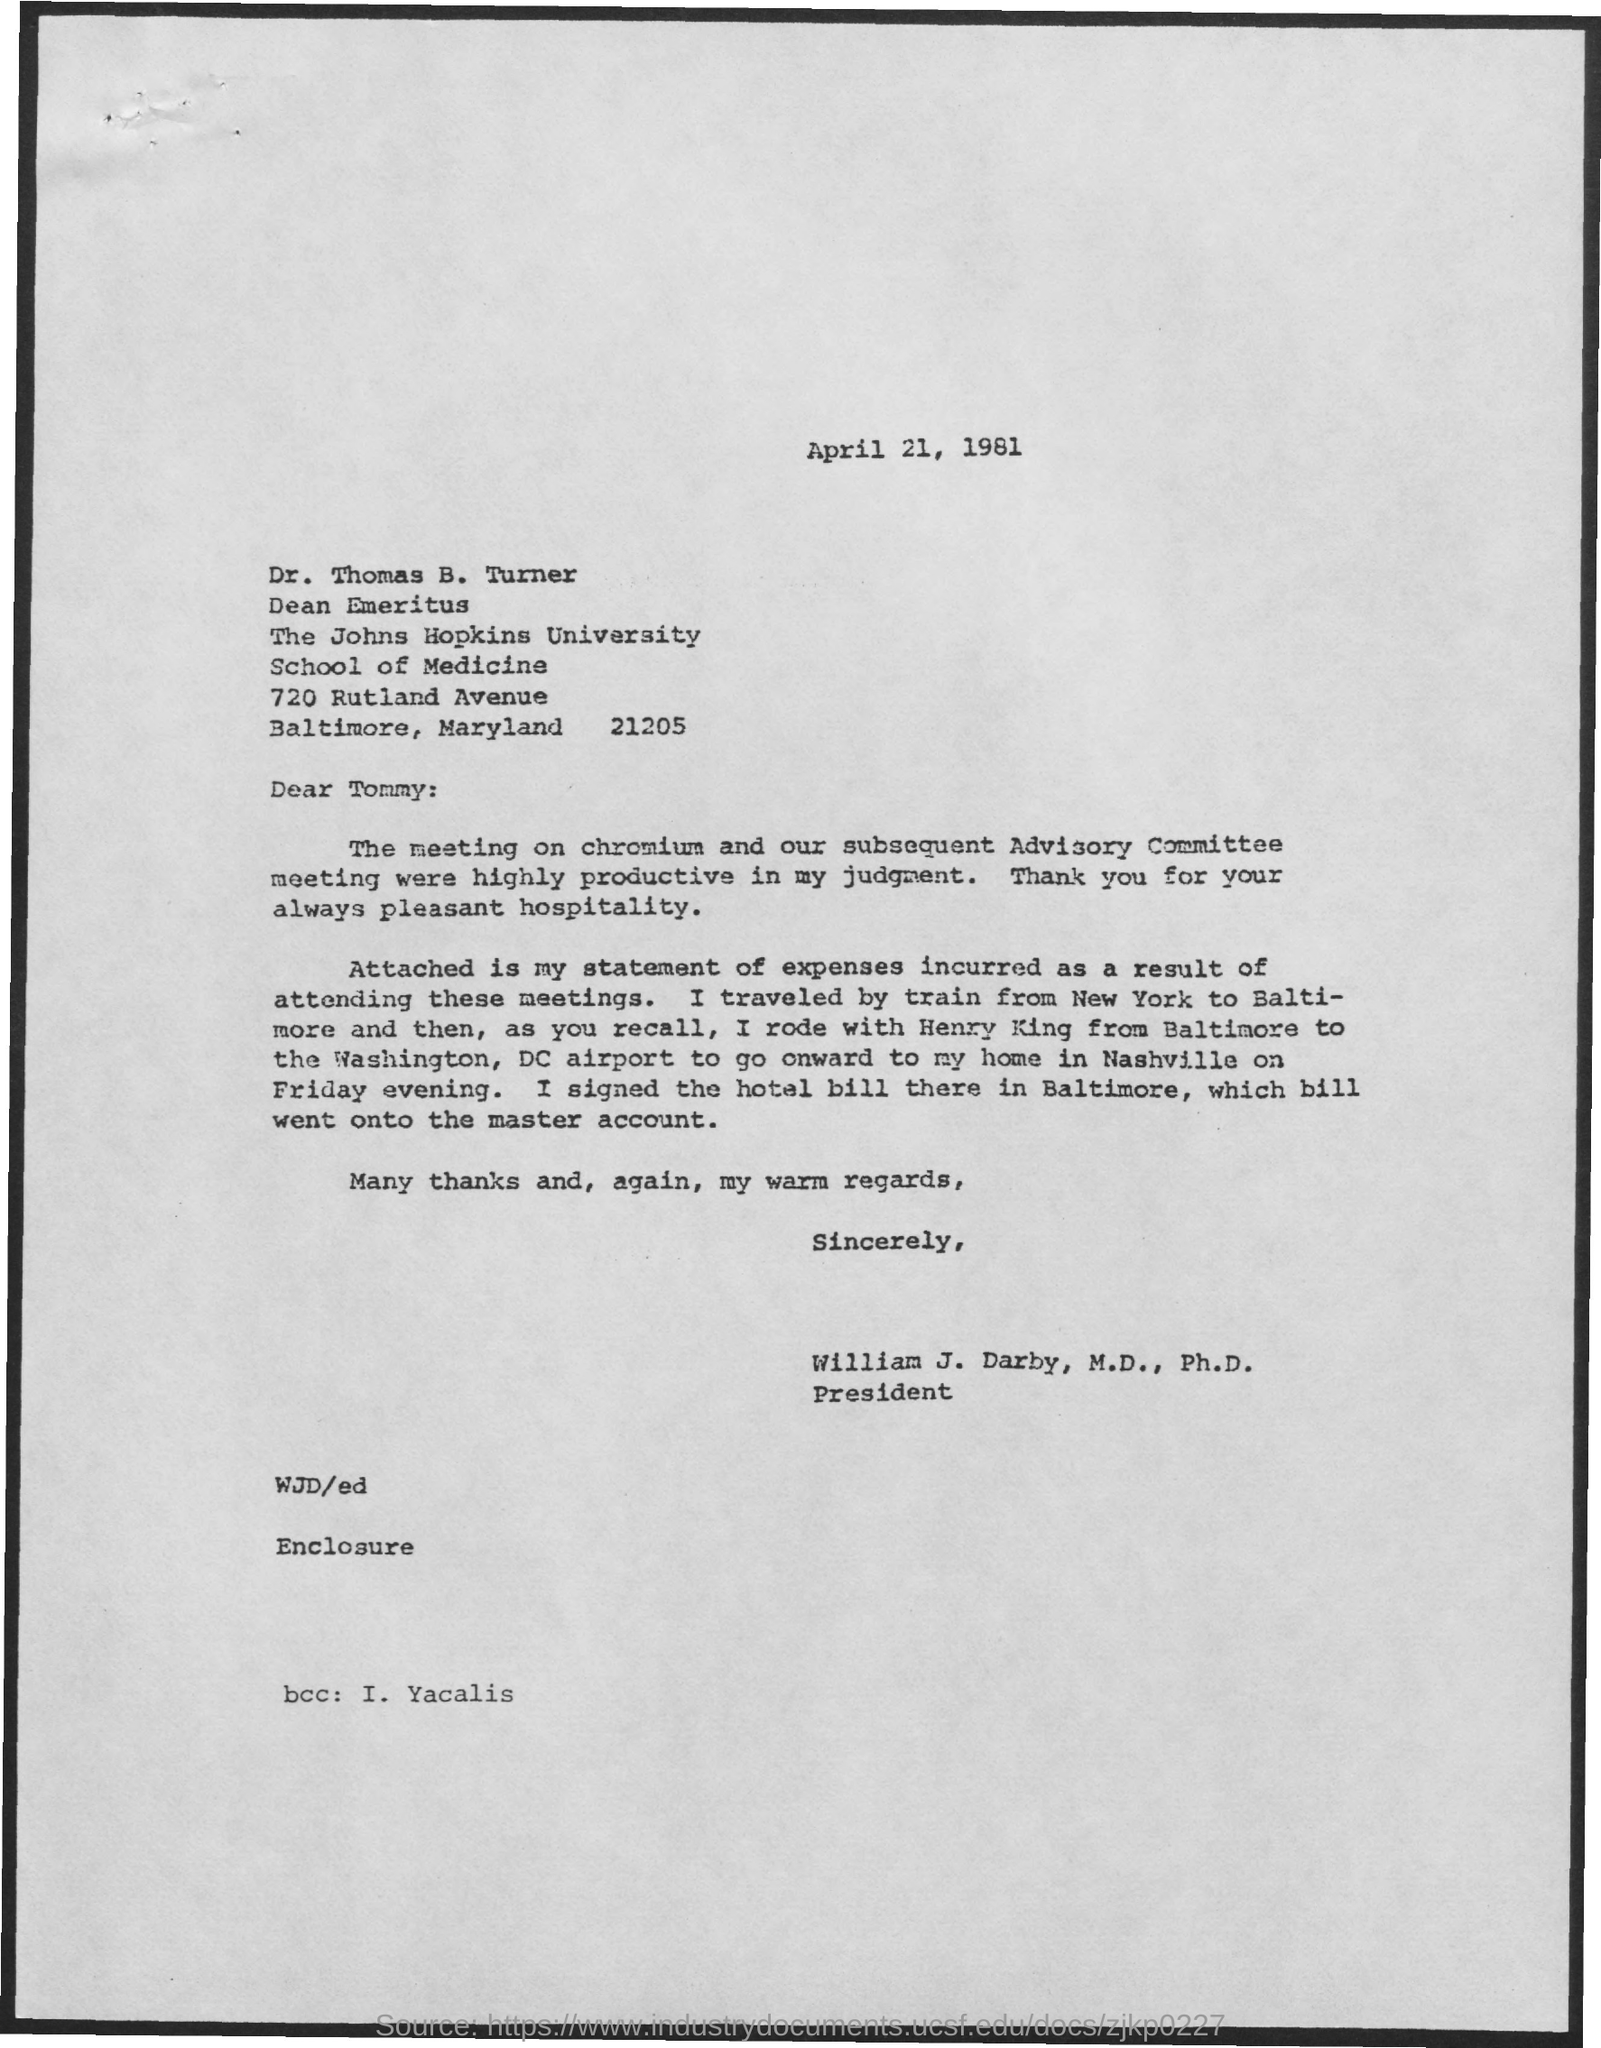What is the date mentioned in this letter?
Keep it short and to the point. April 21, 1981. Who is marked in the bcc of this letter?
Your answer should be very brief. I. Yacalis. Who is the sender of this letter?
Give a very brief answer. William J. Darby, M.D., Ph.D. What is the designation of William J. Darby, M.D., Ph.D.?
Make the answer very short. President. 